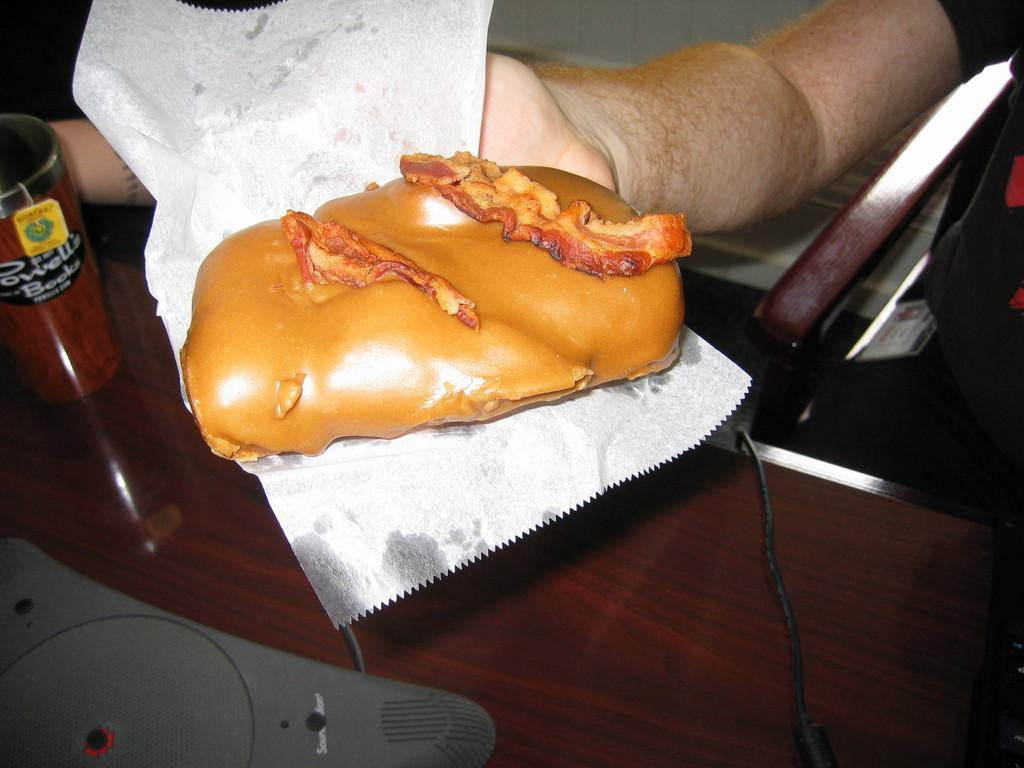What is the person in the image doing? There is a person sitting on a chair in the image, and they are holding a bread in their hand. What is the bread placed on? The bread is placed on a tissue paper. What can be seen on the table in the image? There is a glass on the table. What is on top of the glass? There is an object on the glass. Can you see any wood or streams in the image? No, there is no wood or stream visible in the image. Are there any lizards present in the image? No, there are no lizards present in the image. 